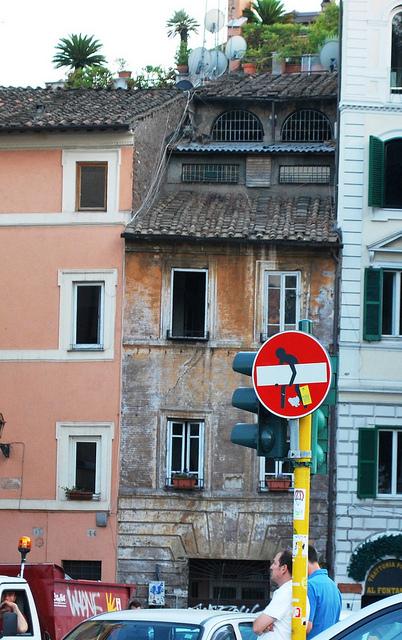How many windows do you see on the pink building?
Short answer required. 3. Why did someone deface the street sign?
Quick response, please. Humor. Is there a satellite dish on the roof of the building?
Short answer required. Yes. 